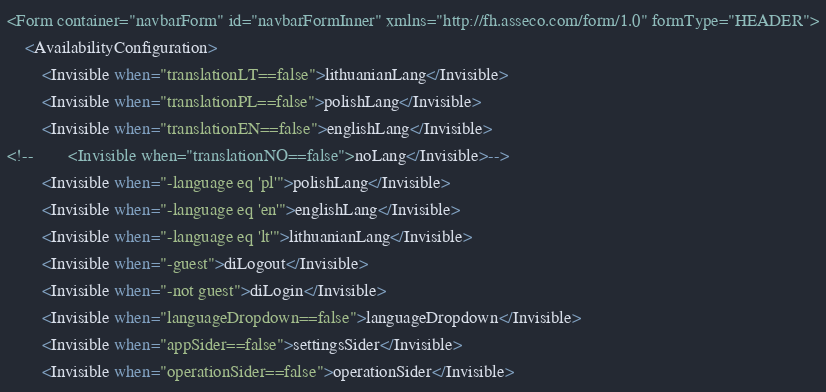Convert code to text. <code><loc_0><loc_0><loc_500><loc_500><_VisualBasic_><Form container="navbarForm" id="navbarFormInner" xmlns="http://fh.asseco.com/form/1.0" formType="HEADER">
    <AvailabilityConfiguration>
        <Invisible when="translationLT==false">lithuanianLang</Invisible>
        <Invisible when="translationPL==false">polishLang</Invisible>
        <Invisible when="translationEN==false">englishLang</Invisible>
<!--        <Invisible when="translationNO==false">noLang</Invisible>-->
        <Invisible when="-language eq 'pl'">polishLang</Invisible>
        <Invisible when="-language eq 'en'">englishLang</Invisible>
        <Invisible when="-language eq 'lt'">lithuanianLang</Invisible>
        <Invisible when="-guest">diLogout</Invisible>
        <Invisible when="-not guest">diLogin</Invisible>
        <Invisible when="languageDropdown==false">languageDropdown</Invisible>
        <Invisible when="appSider==false">settingsSider</Invisible>
        <Invisible when="operationSider==false">operationSider</Invisible></code> 